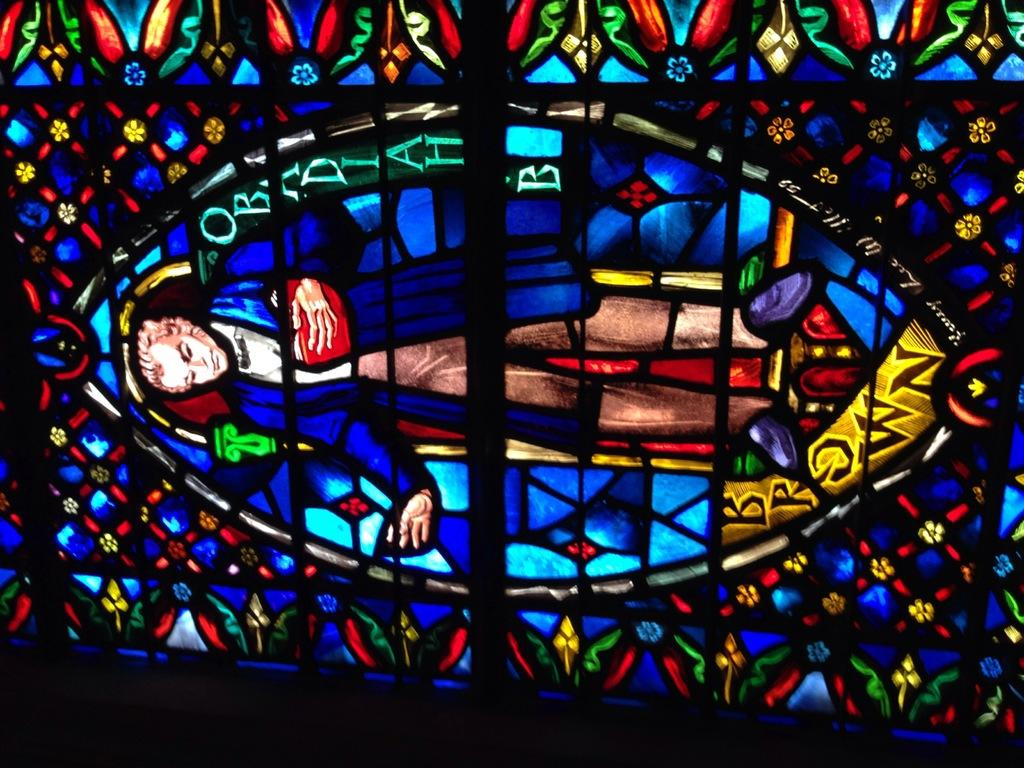What type of glass is depicted in the image? There is a stained glass in the image. Can you describe the appearance of the stained glass? The stained glass may have intricate designs or patterns, as well as various colors. What might be the purpose of the stained glass in the image? The stained glass could be part of a window, door, or other architectural feature, serving a decorative or artistic purpose. How much knowledge does the boy in the image have about the stained glass? There is no boy present in the image, so it is not possible to determine how much knowledge he might have about the stained glass. 